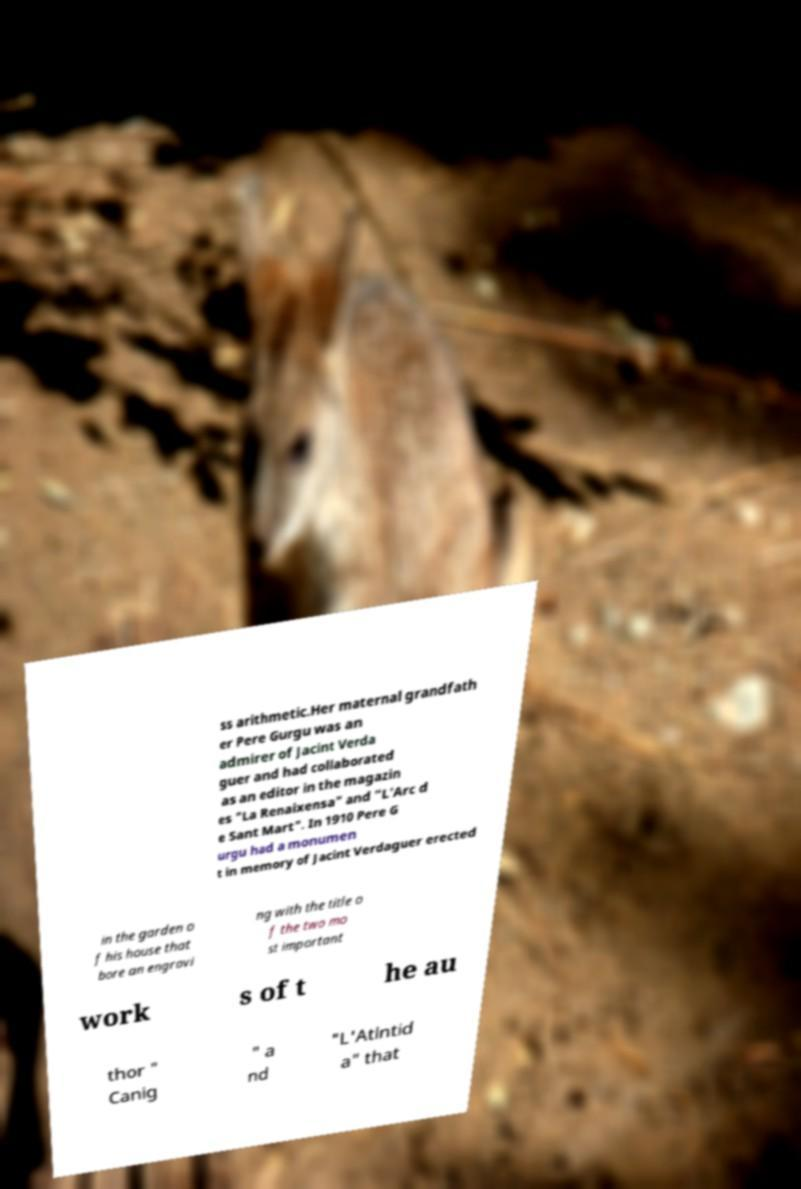There's text embedded in this image that I need extracted. Can you transcribe it verbatim? ss arithmetic.Her maternal grandfath er Pere Gurgu was an admirer of Jacint Verda guer and had collaborated as an editor in the magazin es "La Renaixensa" and "L'Arc d e Sant Mart". In 1910 Pere G urgu had a monumen t in memory of Jacint Verdaguer erected in the garden o f his house that bore an engravi ng with the title o f the two mo st important work s of t he au thor " Canig " a nd "L'Atlntid a" that 